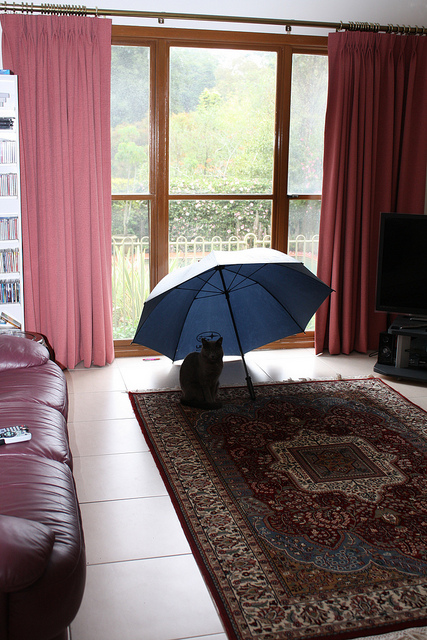Is it raining inside the house? No, it's not raining inside the house. The blue umbrella is open indoors, which is a peculiar sight since umbrellas are typically used outside to protect from rain. The cat seems unbothered by this, perhaps enjoying the cozy shelter it provides. 